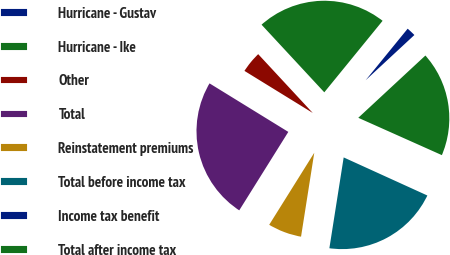Convert chart to OTSL. <chart><loc_0><loc_0><loc_500><loc_500><pie_chart><fcel>Hurricane - Gustav<fcel>Hurricane - Ike<fcel>Other<fcel>Total<fcel>Reinstatement premiums<fcel>Total before income tax<fcel>Income tax benefit<fcel>Total after income tax<nl><fcel>2.21%<fcel>22.79%<fcel>4.31%<fcel>24.89%<fcel>6.41%<fcel>20.69%<fcel>0.11%<fcel>18.59%<nl></chart> 